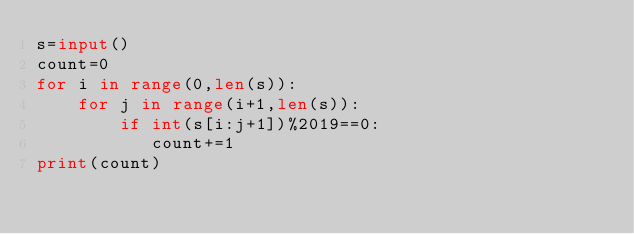<code> <loc_0><loc_0><loc_500><loc_500><_Python_>s=input()
count=0
for i in range(0,len(s)):
    for j in range(i+1,len(s)):
        if int(s[i:j+1])%2019==0:
           count+=1
print(count)</code> 